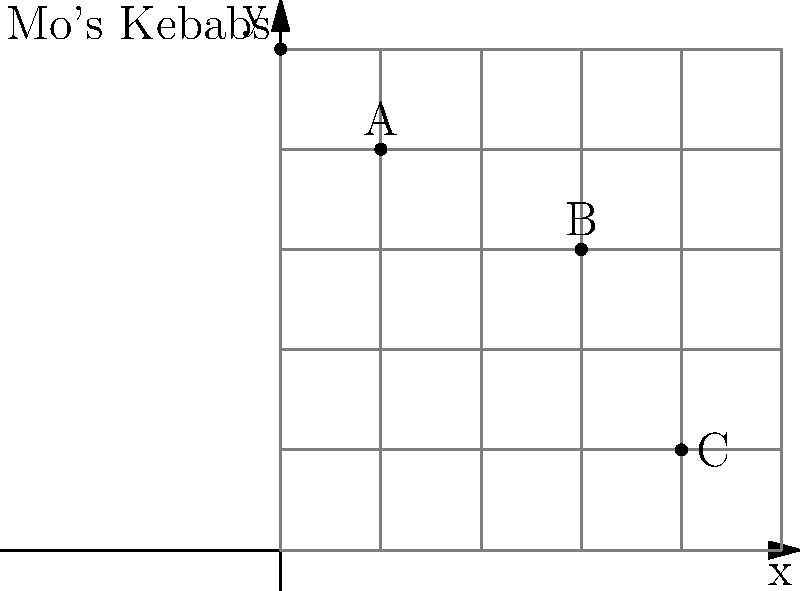Mo's Kebabs needs to deliver orders to three customers: A, B, and C. The restaurant and customers are located on a grid map as shown above, where each unit represents 100 meters. What is the minimum total distance (in meters) that the delivery driver must travel to visit all three customers and return to the restaurant, assuming they can only move horizontally or vertically along the grid lines? Let's approach this step-by-step:

1) First, we need to calculate the coordinates of each point:
   Mo's Kebabs: (0, 5)
   A: (1, 4)
   B: (3, 3)
   C: (4, 1)

2) Now, we need to find the shortest path that visits all points and returns to the start. This is known as the "Traveling Salesman Problem," but in this case, we can solve it by inspection due to the small number of points.

3) The most efficient route appears to be: Mo's → A → B → C → Mo's

4) Let's calculate the distance for each segment:
   Mo's to A: |0-1| + |5-4| = 1 + 1 = 2 units
   A to B: |1-3| + |4-3| = 2 + 1 = 3 units
   B to C: |3-4| + |3-1| = 1 + 2 = 3 units
   C to Mo's: |4-0| + |1-5| = 4 + 4 = 8 units

5) Total distance: 2 + 3 + 3 + 8 = 16 units

6) Since each unit represents 100 meters, the total distance in meters is:
   16 * 100 = 1600 meters

Therefore, the minimum total distance the delivery driver must travel is 1600 meters.
Answer: 1600 meters 